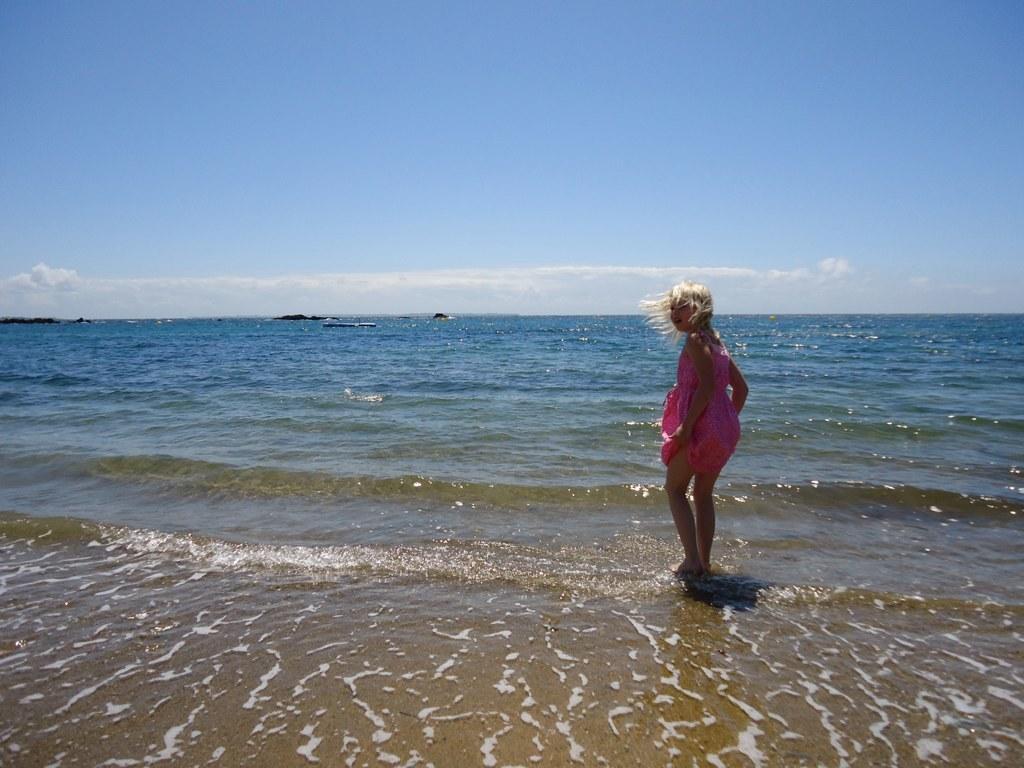In one or two sentences, can you explain what this image depicts? There is a girl standing on water and we can see sky with clouds. 